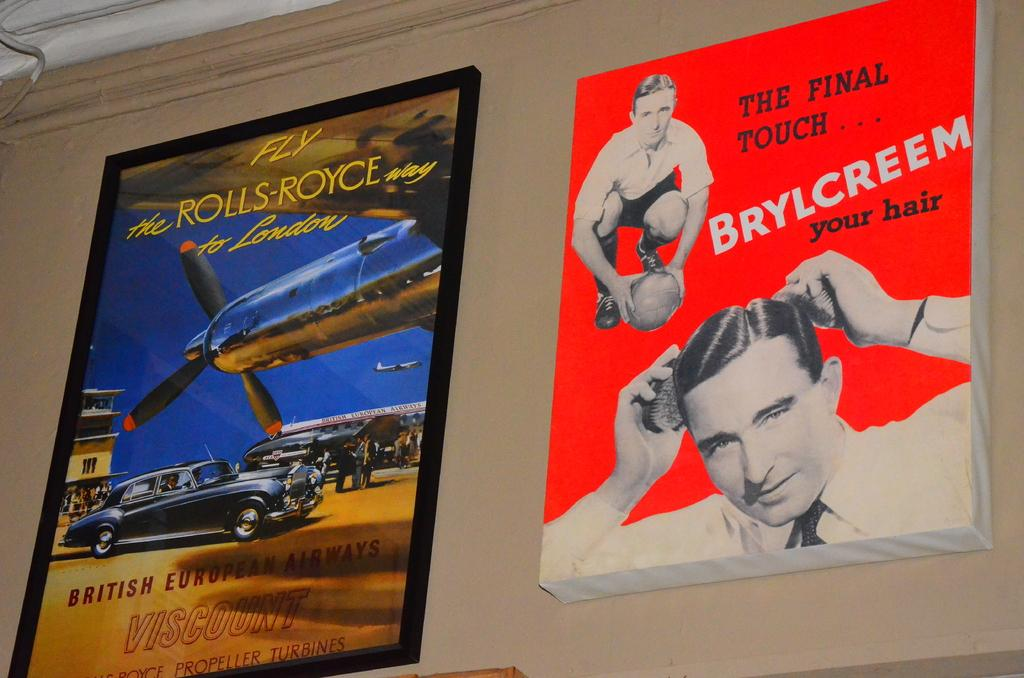Provide a one-sentence caption for the provided image. an advertisement for Brylcreem is hanging beside an ad for flying Rolls Royce. 